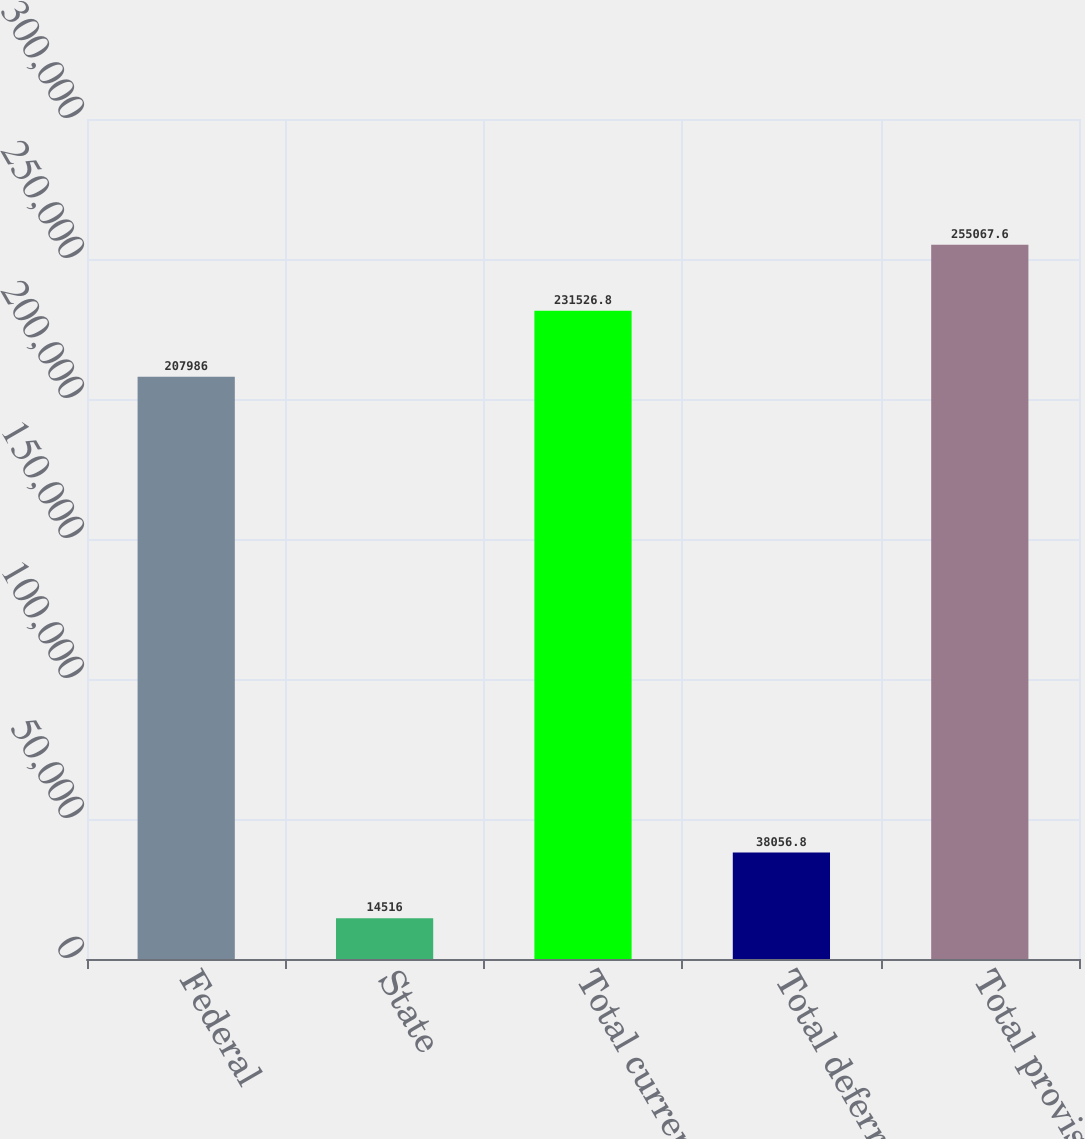<chart> <loc_0><loc_0><loc_500><loc_500><bar_chart><fcel>Federal<fcel>State<fcel>Total current<fcel>Total deferred<fcel>Total provision<nl><fcel>207986<fcel>14516<fcel>231527<fcel>38056.8<fcel>255068<nl></chart> 